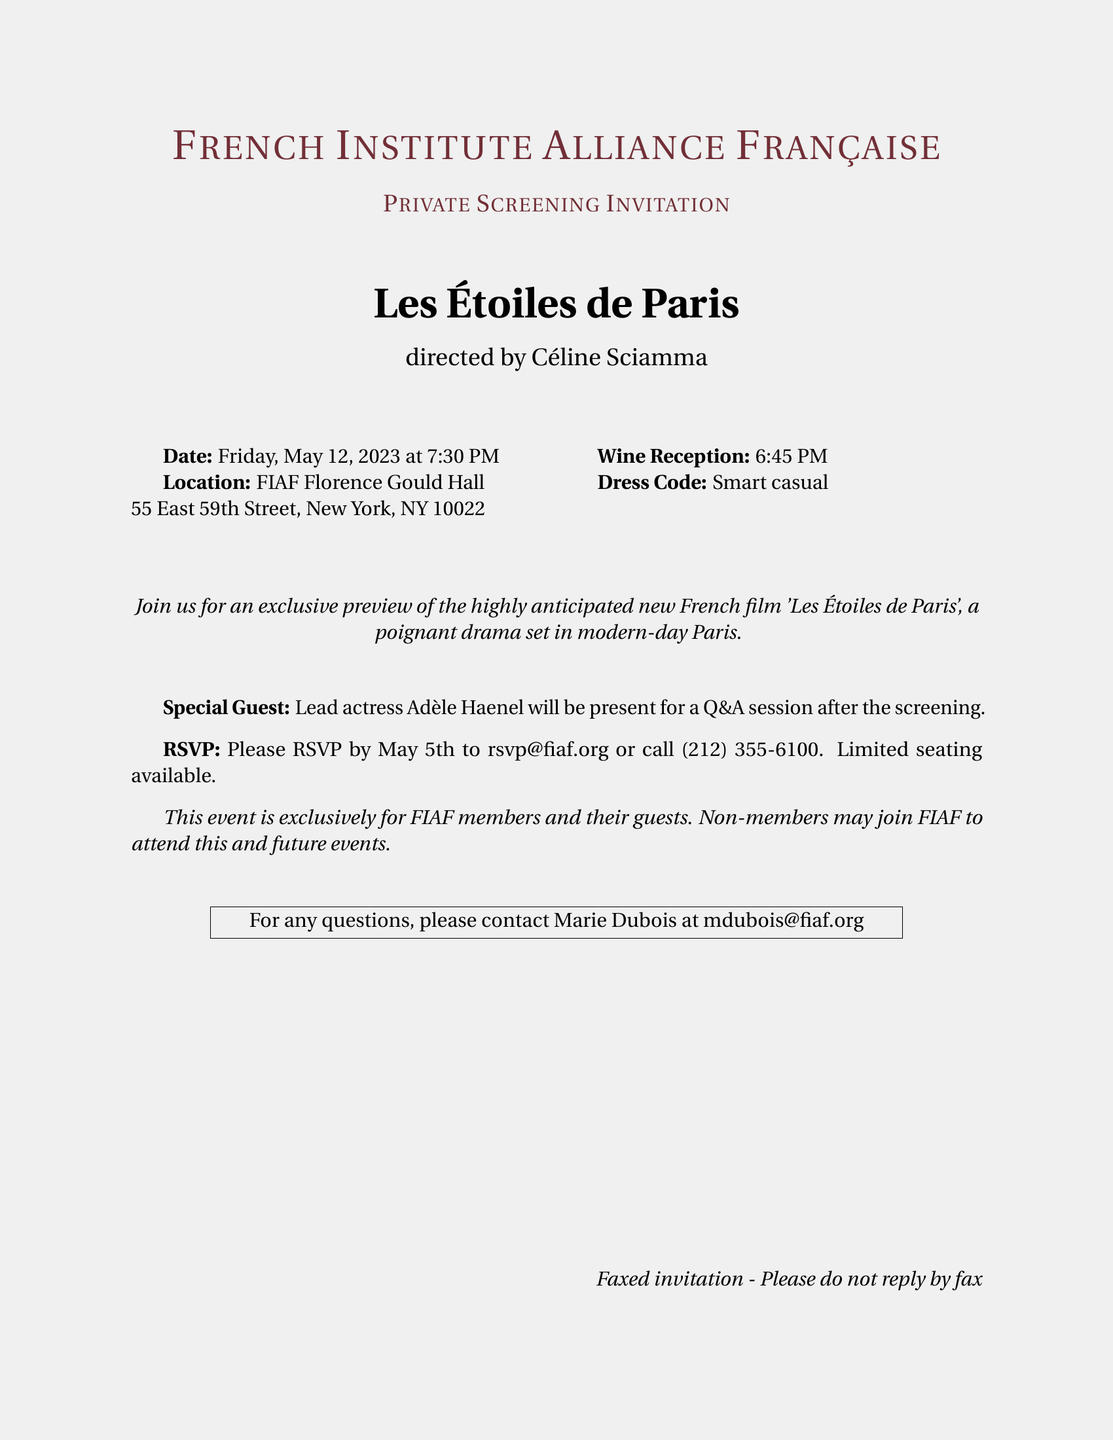What is the name of the film being screened? The name of the film is explicitly stated in the document as 'Les Étoiles de Paris'.
Answer: Les Étoiles de Paris Who is the director of the film? The director is mentioned in the document as Céline Sciamma.
Answer: Céline Sciamma When does the screening begin? The document specifies the screening start time as 7:30 PM.
Answer: 7:30 PM What is the dress code for the event? The dress code is clearly stated as smart casual in the document.
Answer: Smart casual What time does the wine reception start? The document provides the starting time for the wine reception as 6:45 PM.
Answer: 6:45 PM Who will be present for the Q&A session? The document indicates that lead actress Adèle Haenel will be present.
Answer: Adèle Haenel What is the deadline for RSVPs? The deadline for RSVPs is stated as May 5th in the document.
Answer: May 5th What should attendees do if they have questions? The document advises to contact Marie Dubois for any questions.
Answer: Contact Marie Dubois Is the event open to non-members? The document mentions that the event is exclusively for FIAF members.
Answer: No 